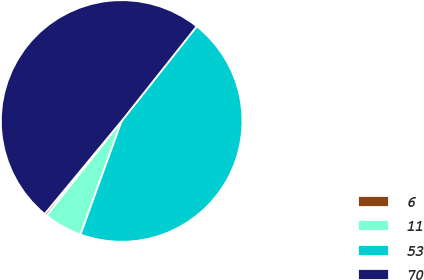<chart> <loc_0><loc_0><loc_500><loc_500><pie_chart><fcel>6<fcel>11<fcel>53<fcel>70<nl><fcel>0.34%<fcel>5.13%<fcel>44.87%<fcel>49.66%<nl></chart> 